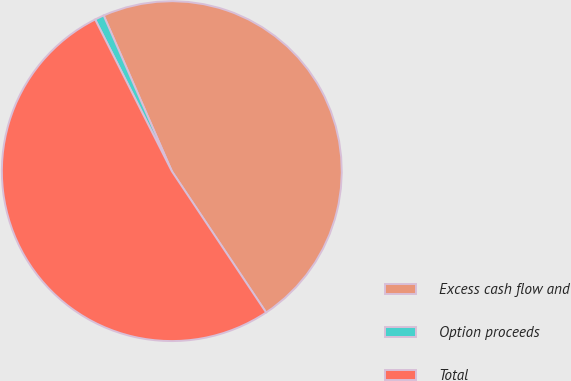Convert chart. <chart><loc_0><loc_0><loc_500><loc_500><pie_chart><fcel>Excess cash flow and<fcel>Option proceeds<fcel>Total<nl><fcel>47.2%<fcel>0.88%<fcel>51.92%<nl></chart> 